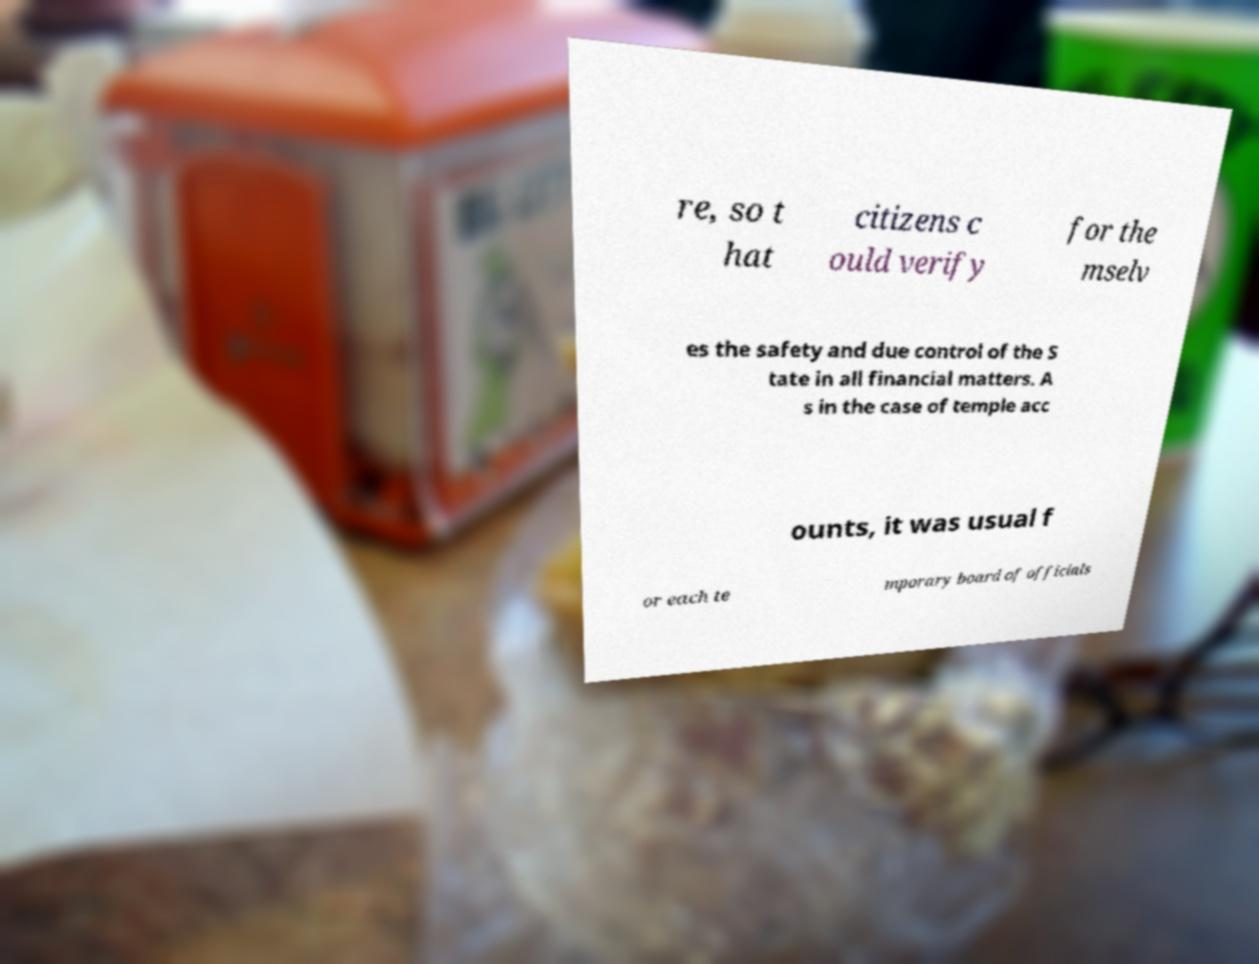Can you accurately transcribe the text from the provided image for me? re, so t hat citizens c ould verify for the mselv es the safety and due control of the S tate in all financial matters. A s in the case of temple acc ounts, it was usual f or each te mporary board of officials 